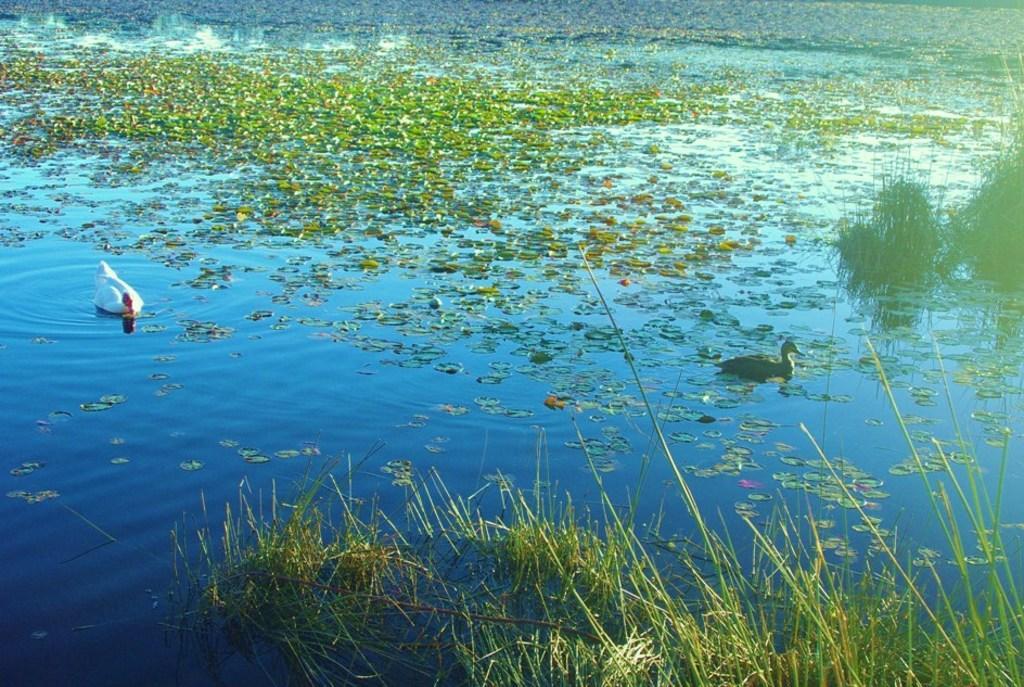Please provide a concise description of this image. In this picture, we can see birds, leaves, plants on water. 